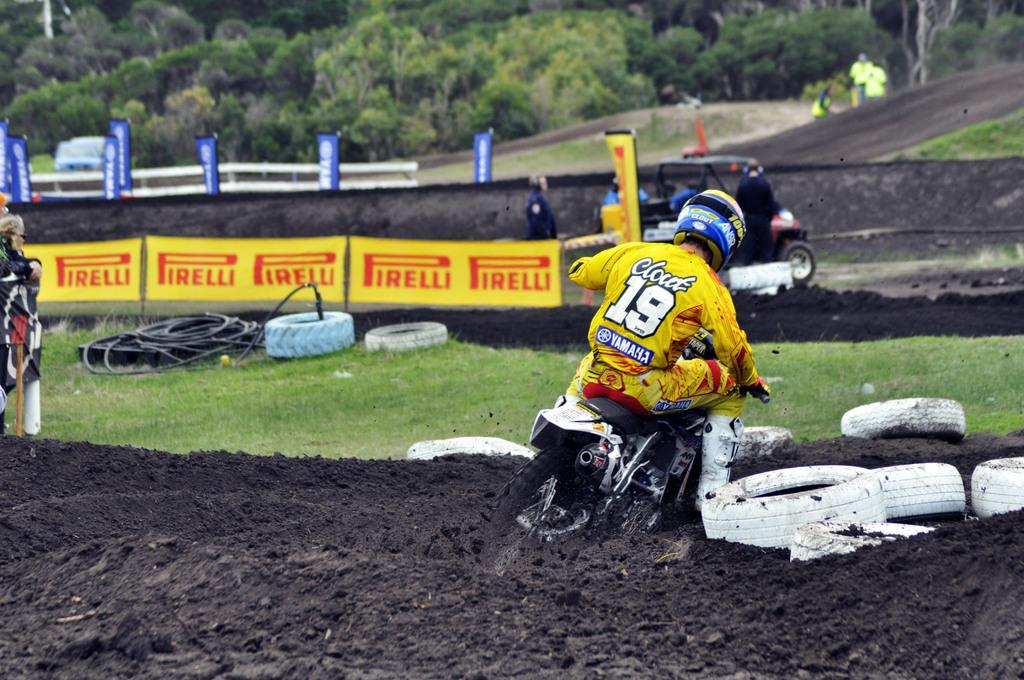What is the main subject of the image? There is a person on a motorcycle in the image. What can be seen on the ground in the image? There are tyres on the ground in the image. How many people are visible in the image? There are people visible in the image. What else can be seen in the image besides the motorcycle and people? There are vehicles, banners, and some objects in the image. What is visible in the background of the image? There are trees in the background of the image. What type of creature is seen kicking a ball in the image? There is no creature or ball present in the image. How many boys are visible in the image? The image does not specify the gender of the people visible, so it cannot be determined if there are any boys present. 